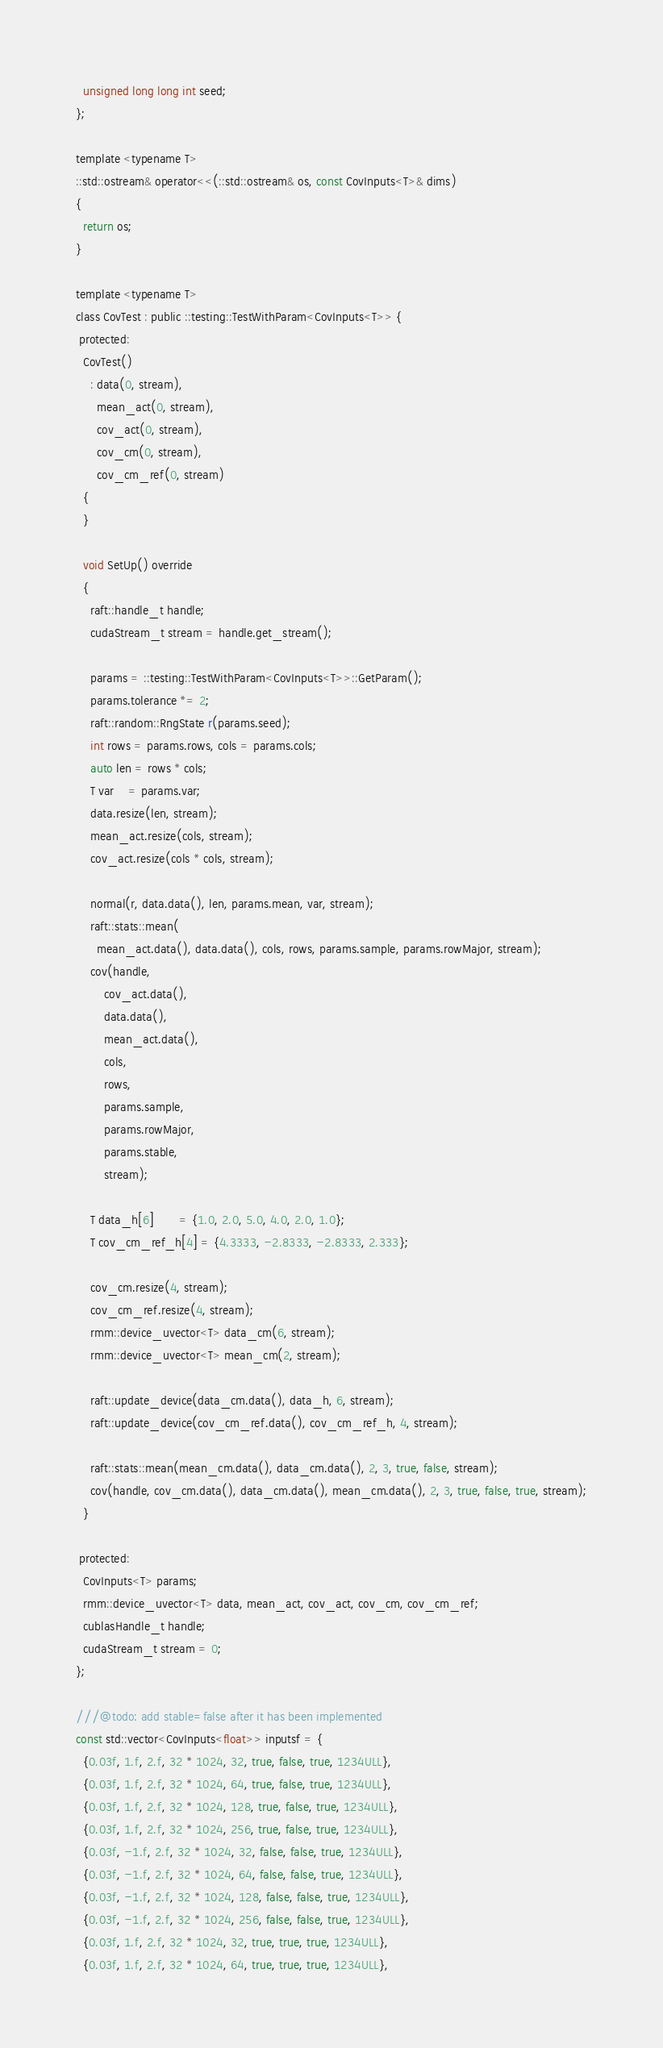Convert code to text. <code><loc_0><loc_0><loc_500><loc_500><_Cuda_>  unsigned long long int seed;
};

template <typename T>
::std::ostream& operator<<(::std::ostream& os, const CovInputs<T>& dims)
{
  return os;
}

template <typename T>
class CovTest : public ::testing::TestWithParam<CovInputs<T>> {
 protected:
  CovTest()
    : data(0, stream),
      mean_act(0, stream),
      cov_act(0, stream),
      cov_cm(0, stream),
      cov_cm_ref(0, stream)
  {
  }

  void SetUp() override
  {
    raft::handle_t handle;
    cudaStream_t stream = handle.get_stream();

    params = ::testing::TestWithParam<CovInputs<T>>::GetParam();
    params.tolerance *= 2;
    raft::random::RngState r(params.seed);
    int rows = params.rows, cols = params.cols;
    auto len = rows * cols;
    T var    = params.var;
    data.resize(len, stream);
    mean_act.resize(cols, stream);
    cov_act.resize(cols * cols, stream);

    normal(r, data.data(), len, params.mean, var, stream);
    raft::stats::mean(
      mean_act.data(), data.data(), cols, rows, params.sample, params.rowMajor, stream);
    cov(handle,
        cov_act.data(),
        data.data(),
        mean_act.data(),
        cols,
        rows,
        params.sample,
        params.rowMajor,
        params.stable,
        stream);

    T data_h[6]       = {1.0, 2.0, 5.0, 4.0, 2.0, 1.0};
    T cov_cm_ref_h[4] = {4.3333, -2.8333, -2.8333, 2.333};

    cov_cm.resize(4, stream);
    cov_cm_ref.resize(4, stream);
    rmm::device_uvector<T> data_cm(6, stream);
    rmm::device_uvector<T> mean_cm(2, stream);

    raft::update_device(data_cm.data(), data_h, 6, stream);
    raft::update_device(cov_cm_ref.data(), cov_cm_ref_h, 4, stream);

    raft::stats::mean(mean_cm.data(), data_cm.data(), 2, 3, true, false, stream);
    cov(handle, cov_cm.data(), data_cm.data(), mean_cm.data(), 2, 3, true, false, true, stream);
  }

 protected:
  CovInputs<T> params;
  rmm::device_uvector<T> data, mean_act, cov_act, cov_cm, cov_cm_ref;
  cublasHandle_t handle;
  cudaStream_t stream = 0;
};

///@todo: add stable=false after it has been implemented
const std::vector<CovInputs<float>> inputsf = {
  {0.03f, 1.f, 2.f, 32 * 1024, 32, true, false, true, 1234ULL},
  {0.03f, 1.f, 2.f, 32 * 1024, 64, true, false, true, 1234ULL},
  {0.03f, 1.f, 2.f, 32 * 1024, 128, true, false, true, 1234ULL},
  {0.03f, 1.f, 2.f, 32 * 1024, 256, true, false, true, 1234ULL},
  {0.03f, -1.f, 2.f, 32 * 1024, 32, false, false, true, 1234ULL},
  {0.03f, -1.f, 2.f, 32 * 1024, 64, false, false, true, 1234ULL},
  {0.03f, -1.f, 2.f, 32 * 1024, 128, false, false, true, 1234ULL},
  {0.03f, -1.f, 2.f, 32 * 1024, 256, false, false, true, 1234ULL},
  {0.03f, 1.f, 2.f, 32 * 1024, 32, true, true, true, 1234ULL},
  {0.03f, 1.f, 2.f, 32 * 1024, 64, true, true, true, 1234ULL},</code> 